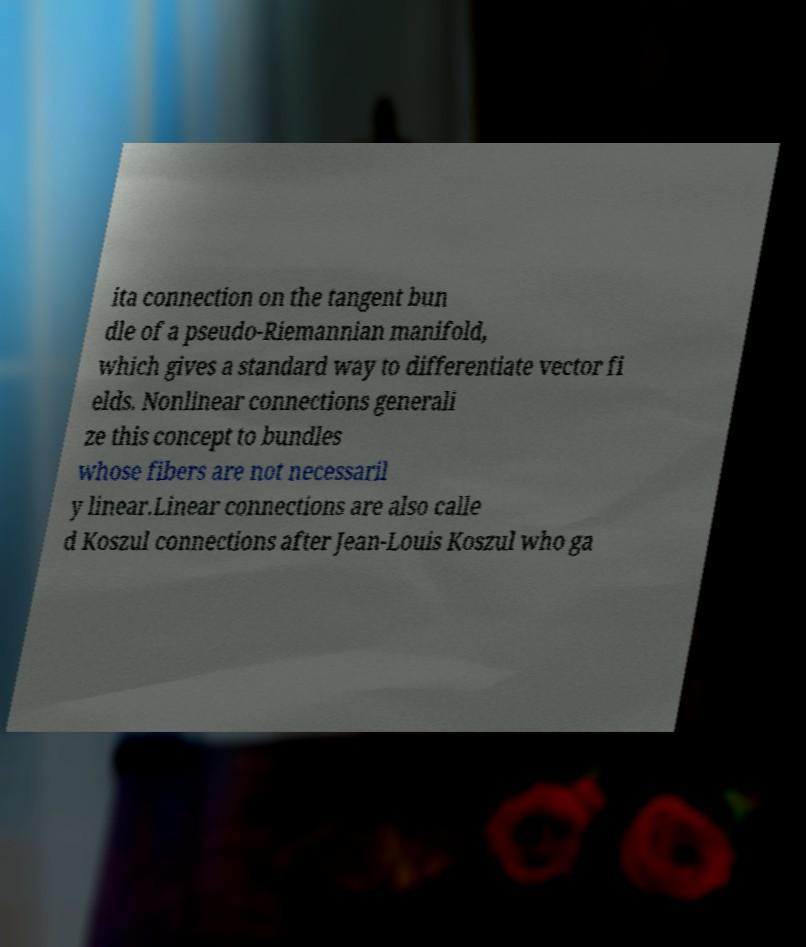Can you read and provide the text displayed in the image?This photo seems to have some interesting text. Can you extract and type it out for me? ita connection on the tangent bun dle of a pseudo-Riemannian manifold, which gives a standard way to differentiate vector fi elds. Nonlinear connections generali ze this concept to bundles whose fibers are not necessaril y linear.Linear connections are also calle d Koszul connections after Jean-Louis Koszul who ga 